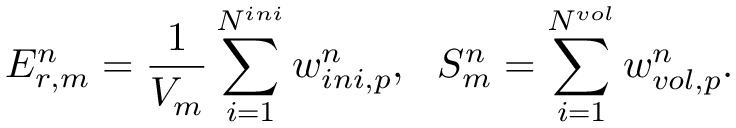<formula> <loc_0><loc_0><loc_500><loc_500>E _ { r , m } ^ { n } = \frac { 1 } { V _ { m } } \sum _ { i = 1 } ^ { N ^ { i n i } } w _ { i n i , p } ^ { n } , \ \ S _ { m } ^ { n } = \sum _ { i = 1 } ^ { N ^ { v o l } } w _ { v o l , p } ^ { n } .</formula> 